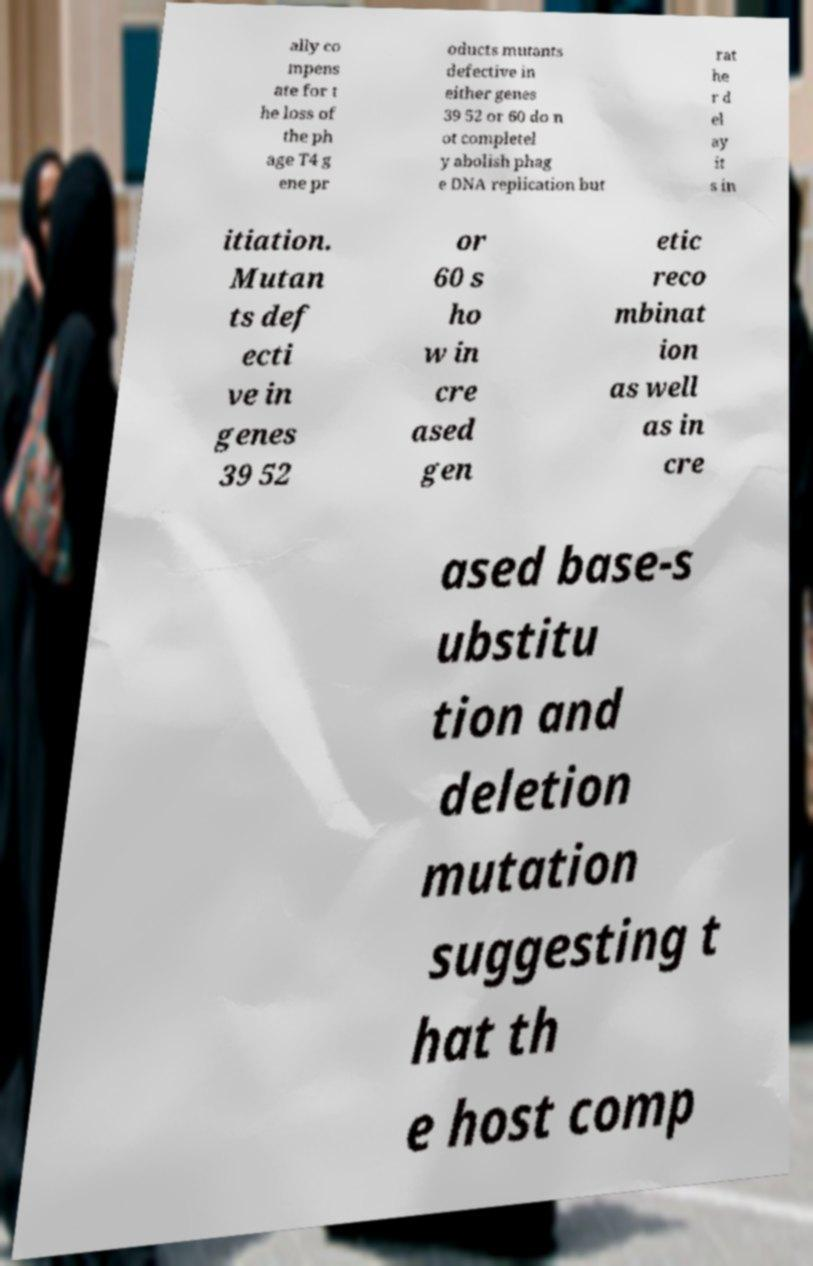What messages or text are displayed in this image? I need them in a readable, typed format. ally co mpens ate for t he loss of the ph age T4 g ene pr oducts mutants defective in either genes 39 52 or 60 do n ot completel y abolish phag e DNA replication but rat he r d el ay it s in itiation. Mutan ts def ecti ve in genes 39 52 or 60 s ho w in cre ased gen etic reco mbinat ion as well as in cre ased base-s ubstitu tion and deletion mutation suggesting t hat th e host comp 